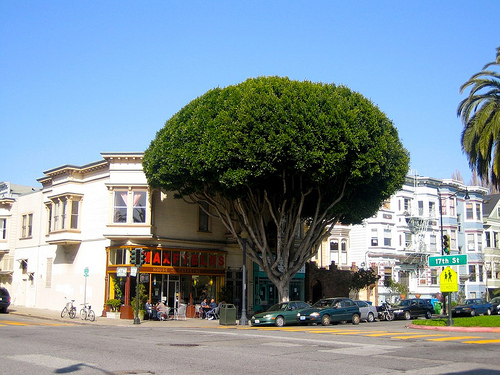<image>
Is the tree behind the building? No. The tree is not behind the building. From this viewpoint, the tree appears to be positioned elsewhere in the scene. Where is the building in relation to the tree? Is it in front of the tree? No. The building is not in front of the tree. The spatial positioning shows a different relationship between these objects. 